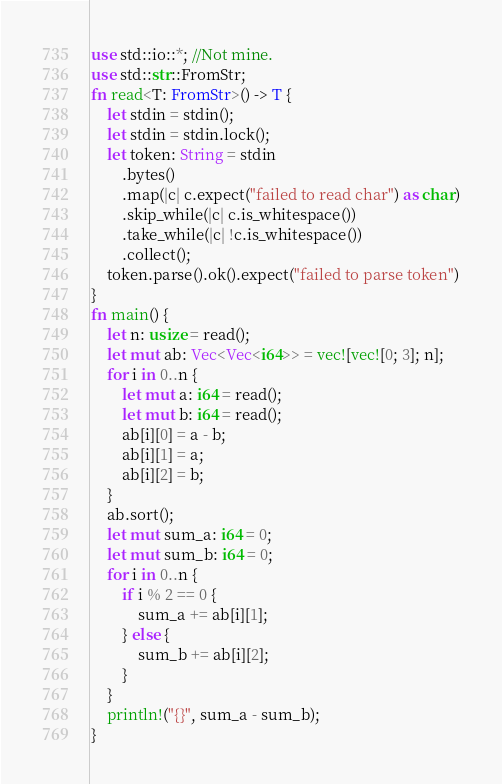Convert code to text. <code><loc_0><loc_0><loc_500><loc_500><_Rust_>use std::io::*; //Not mine.
use std::str::FromStr;
fn read<T: FromStr>() -> T {
    let stdin = stdin();
    let stdin = stdin.lock();
    let token: String = stdin
        .bytes()
        .map(|c| c.expect("failed to read char") as char)
        .skip_while(|c| c.is_whitespace())
        .take_while(|c| !c.is_whitespace())
        .collect();
    token.parse().ok().expect("failed to parse token")
}
fn main() {
    let n: usize = read();
    let mut ab: Vec<Vec<i64>> = vec![vec![0; 3]; n];
    for i in 0..n {
        let mut a: i64 = read();
        let mut b: i64 = read();
        ab[i][0] = a - b;
        ab[i][1] = a;
        ab[i][2] = b;
    }
    ab.sort();
    let mut sum_a: i64 = 0;
    let mut sum_b: i64 = 0;
    for i in 0..n {
        if i % 2 == 0 {
            sum_a += ab[i][1];
        } else {
            sum_b += ab[i][2];
        }
    }
    println!("{}", sum_a - sum_b);
}
</code> 